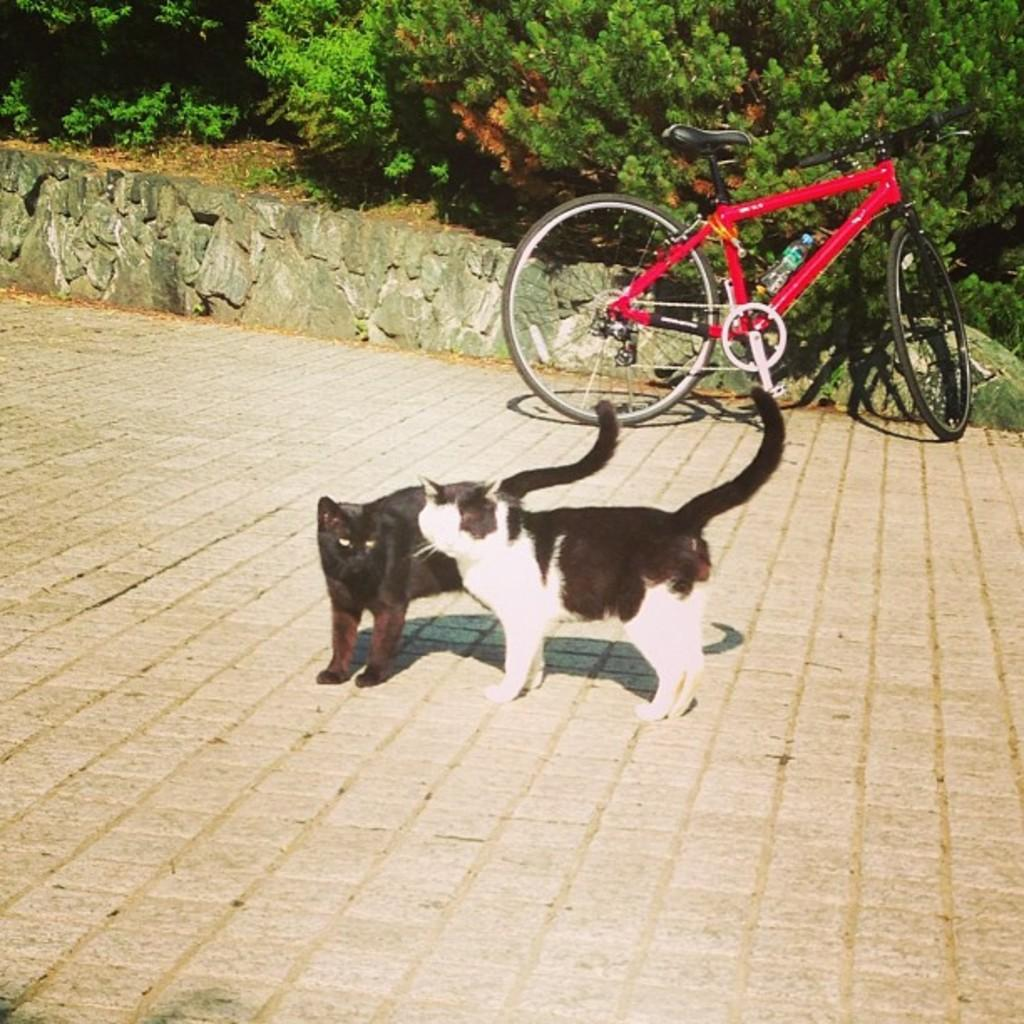What animals are in the center of the image? There are two cats in the center of the image. What can be seen in the background of the image? There are trees, soil, a wall, and a bicycle visible in the background of the image. What type of yak can be seen grazing near the wall in the image? There is no yak present in the image; it features two cats and various background elements. 